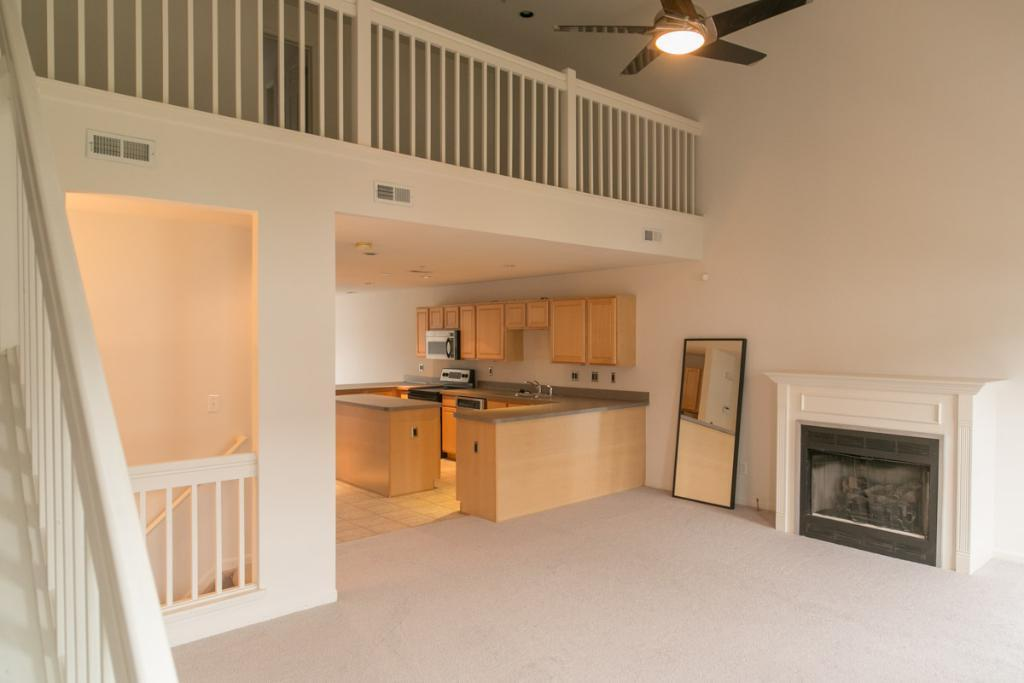What reflective object can be seen in the image? There is a mirror in the image. What type of surface is visible in the image? Counter tops are visible in the image. What type of storage is present in the image? There are cupboards in the image. What kitchen appliance is present in the image? A microwave is present in the image. What type of fixture is visible in the image? Water taps are visible in the image. What type of architectural feature is present in the image? Railings are present in the image. What type of device is visible in the image? A ceiling fan is visible in the image. How many giants are visible in the image? There are no giants present in the image. What type of rhythm can be heard in the image? There is no sound or music in the image, so it is not possible to determine any rhythm. 